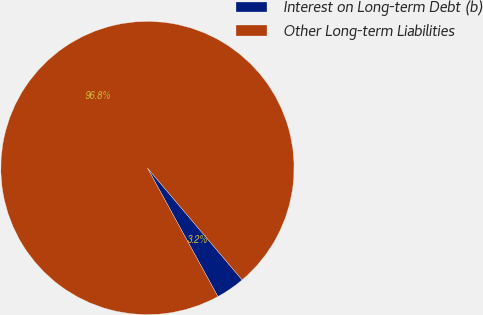<chart> <loc_0><loc_0><loc_500><loc_500><pie_chart><fcel>Interest on Long-term Debt (b)<fcel>Other Long-term Liabilities<nl><fcel>3.2%<fcel>96.8%<nl></chart> 